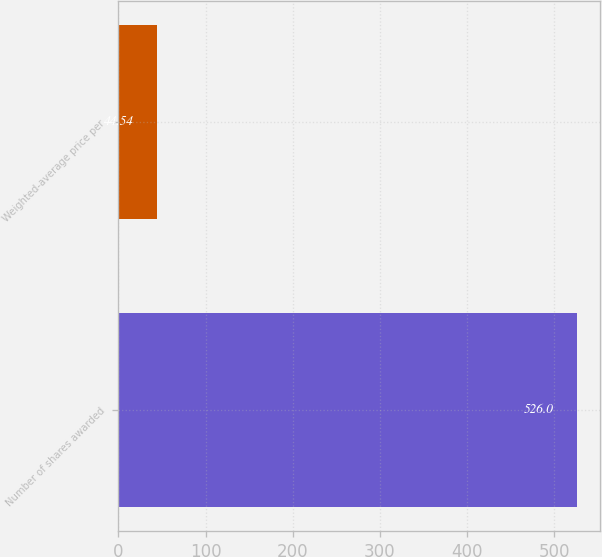<chart> <loc_0><loc_0><loc_500><loc_500><bar_chart><fcel>Number of shares awarded<fcel>Weighted-average price per<nl><fcel>526<fcel>44.54<nl></chart> 